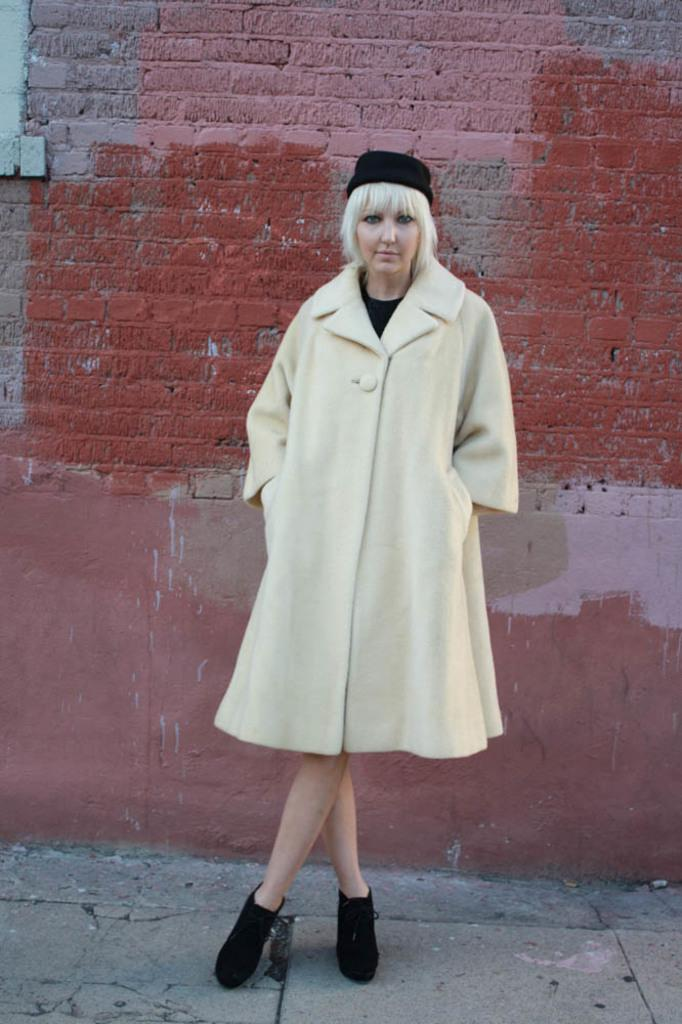Who is present in the image? There is a woman in the image. What is the woman doing in the image? The woman is standing in the image. What is the woman wearing in the image? The woman is wearing a coat and a cap in the image. What color is the coat the woman is wearing? The coat is in cream color. What is the woman wearing on her head? The woman is wearing a hat in the image. What is visible behind the woman in the image? There is a wall behind the woman in the image. How does the woman use the beam in the image? There is no beam present in the image; it only features a woman, a wall, and her clothing. 